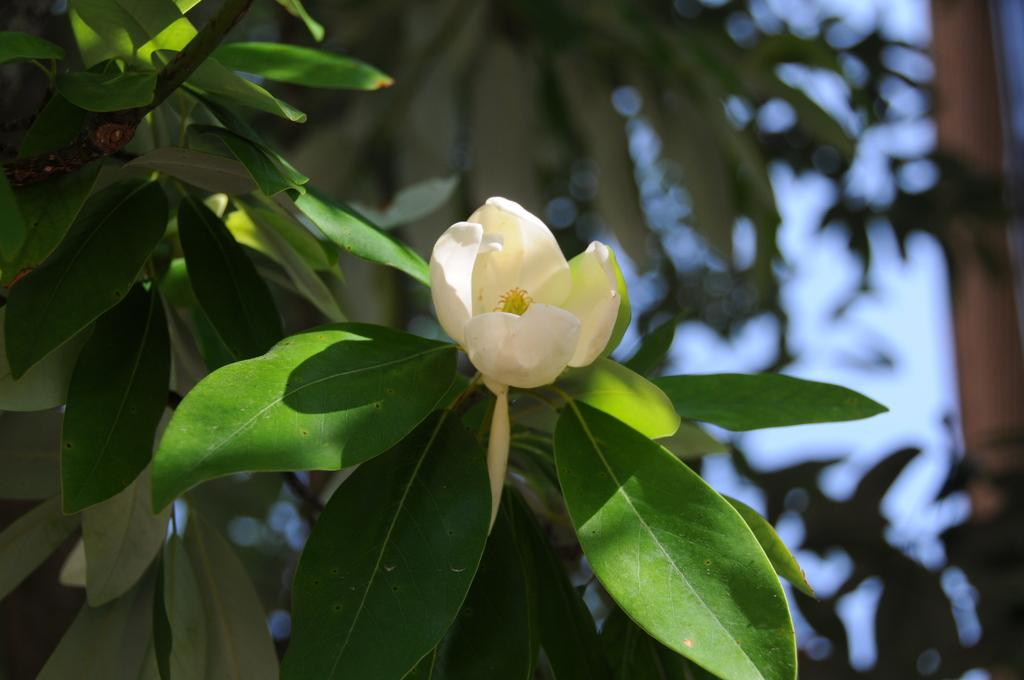What is the main subject of the image? There is a flower in the center of the image. Can you describe the color of the flower? The flower is white. What can be seen in the background of the image? There are trees and the sky visible in the background of the image. How much money is being exchanged in the image? There is no money being exchanged in the image; it features a white flower with trees and the sky in the background. What type of patch is visible on the flower in the image? There is no patch visible on the flower in the image; it is a simple white flower. 